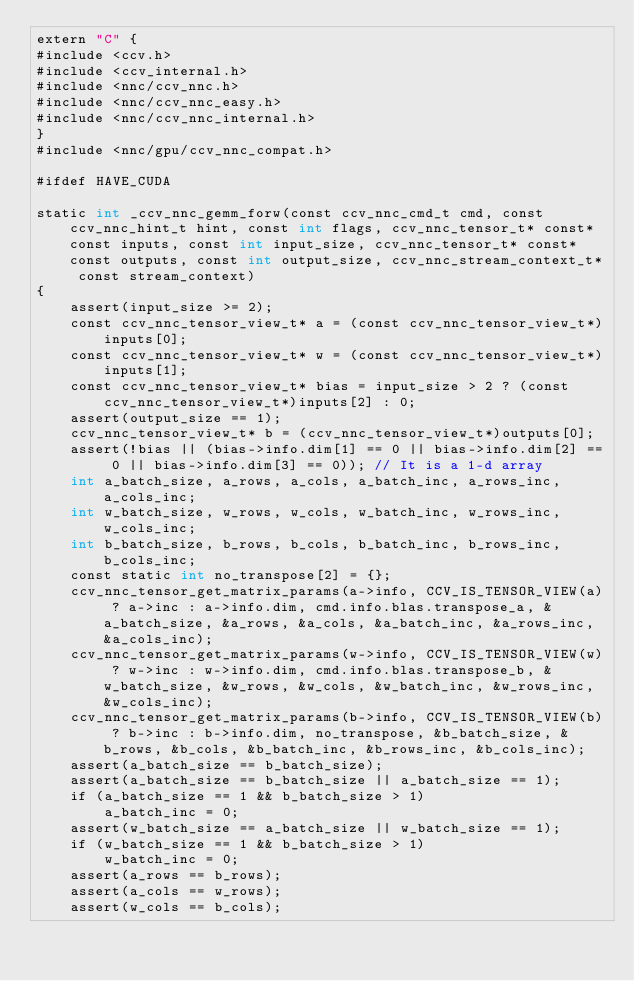Convert code to text. <code><loc_0><loc_0><loc_500><loc_500><_Cuda_>extern "C" {
#include <ccv.h>
#include <ccv_internal.h>
#include <nnc/ccv_nnc.h>
#include <nnc/ccv_nnc_easy.h>
#include <nnc/ccv_nnc_internal.h>
}
#include <nnc/gpu/ccv_nnc_compat.h>

#ifdef HAVE_CUDA

static int _ccv_nnc_gemm_forw(const ccv_nnc_cmd_t cmd, const ccv_nnc_hint_t hint, const int flags, ccv_nnc_tensor_t* const* const inputs, const int input_size, ccv_nnc_tensor_t* const* const outputs, const int output_size, ccv_nnc_stream_context_t* const stream_context)
{
	assert(input_size >= 2);
	const ccv_nnc_tensor_view_t* a = (const ccv_nnc_tensor_view_t*)inputs[0];
	const ccv_nnc_tensor_view_t* w = (const ccv_nnc_tensor_view_t*)inputs[1];
	const ccv_nnc_tensor_view_t* bias = input_size > 2 ? (const ccv_nnc_tensor_view_t*)inputs[2] : 0;
	assert(output_size == 1);
	ccv_nnc_tensor_view_t* b = (ccv_nnc_tensor_view_t*)outputs[0];
	assert(!bias || (bias->info.dim[1] == 0 || bias->info.dim[2] == 0 || bias->info.dim[3] == 0)); // It is a 1-d array
	int a_batch_size, a_rows, a_cols, a_batch_inc, a_rows_inc, a_cols_inc;
	int w_batch_size, w_rows, w_cols, w_batch_inc, w_rows_inc, w_cols_inc;
	int b_batch_size, b_rows, b_cols, b_batch_inc, b_rows_inc, b_cols_inc;
	const static int no_transpose[2] = {};
	ccv_nnc_tensor_get_matrix_params(a->info, CCV_IS_TENSOR_VIEW(a) ? a->inc : a->info.dim, cmd.info.blas.transpose_a, &a_batch_size, &a_rows, &a_cols, &a_batch_inc, &a_rows_inc, &a_cols_inc);
	ccv_nnc_tensor_get_matrix_params(w->info, CCV_IS_TENSOR_VIEW(w) ? w->inc : w->info.dim, cmd.info.blas.transpose_b, &w_batch_size, &w_rows, &w_cols, &w_batch_inc, &w_rows_inc, &w_cols_inc);
	ccv_nnc_tensor_get_matrix_params(b->info, CCV_IS_TENSOR_VIEW(b) ? b->inc : b->info.dim, no_transpose, &b_batch_size, &b_rows, &b_cols, &b_batch_inc, &b_rows_inc, &b_cols_inc);
	assert(a_batch_size == b_batch_size);
	assert(a_batch_size == b_batch_size || a_batch_size == 1);
	if (a_batch_size == 1 && b_batch_size > 1)
		a_batch_inc = 0;
	assert(w_batch_size == a_batch_size || w_batch_size == 1);
	if (w_batch_size == 1 && b_batch_size > 1)
		w_batch_inc = 0;
	assert(a_rows == b_rows);
	assert(a_cols == w_rows);
	assert(w_cols == b_cols);</code> 